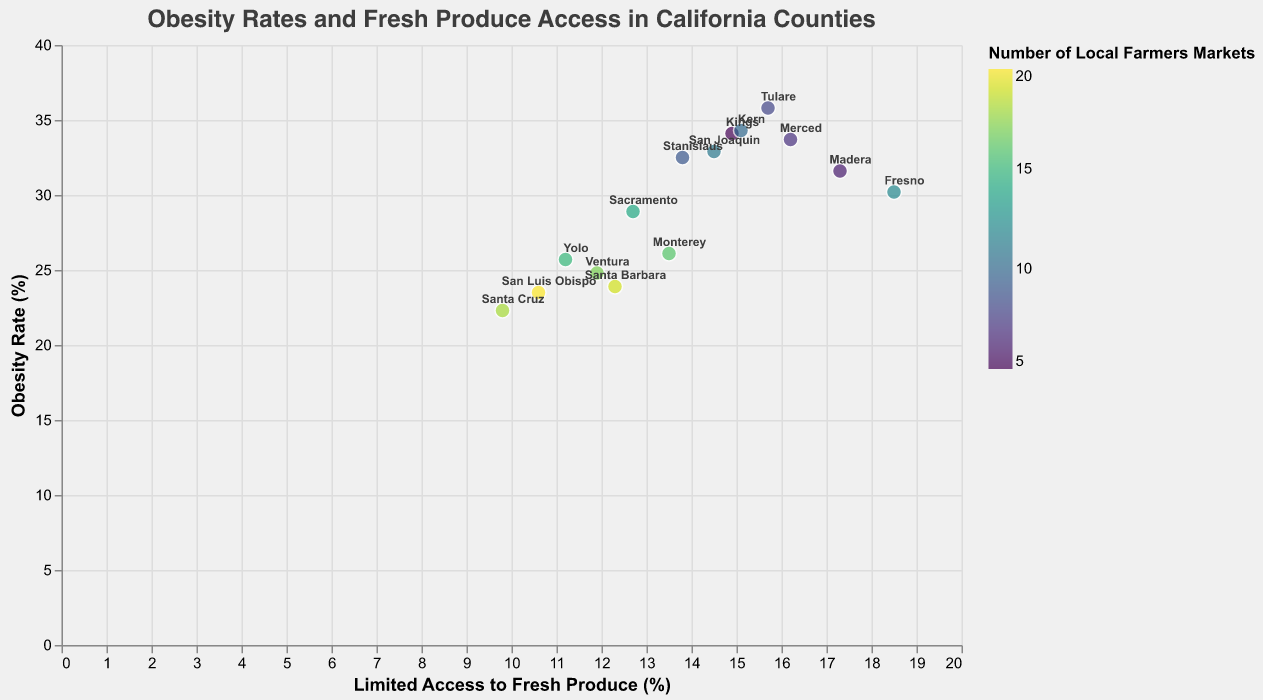What is the title of the plot? The title is displayed at the top of the plot in larger font. It reads “Obesity Rates and Fresh Produce Access in California Counties”.
Answer: Obesity Rates and Fresh Produce Access in California Counties What do the x and y-axes represent? The x-axis depicts the percentage of people with limited access to fresh produce, and the y-axis shows the obesity rate percentage in each county.
Answer: The x-axis represents Limited Access to Fresh Produce (%) and the y-axis represents Obesity Rate (%) Which county has the highest obesity rate? By looking at the highest point on the y-axis, the county with the highest obesity rate is Tulare with an obesity rate of 35.8%.
Answer: Tulare How many counties have an obesity rate higher than 30%? By examining the points above the 30% mark on the y-axis, we can count the number of counties. These points are for Fresno, Tulare, Kings, Merced, Stanislaus, San Joaquin, Madera, and Kern, making it 8 counties.
Answer: 8 Which county has the lowest access to fresh produce? By finding the point farthest to the right on the x-axis, the county with the highest value of limited access to fresh produce is Fresno with 18.5%.
Answer: Fresno Compare the number of local farmers markets in counties with obesity rates above 30% and those below. Identify counties with obesity rates above and below 30%. Above 30% includes Fresno, Tulare, Kings, Merced, Stanislaus, San Joaquin, Madera, and Kern with a total of (12+8+5+7+9+11+6+10)=68 markets. Below 30% includes Yolo, Sacramento, Santa Cruz, Monterey, San Luis Obispo, Ventura, and Santa Barbara with a total of (15+14+18+16+20+17+19)=119 markets.
Answer: Above 30%: 68 markets, Below 30%: 119 markets What's the median obesity rate for the counties plotted? Order the obesity rates: 22.3, 23.5, 23.9, 24.8, 25.7, 26.1, 28.9, 30.2, 31.6, 32.5, 32.9, 33.7, 34.1, 34.3, 35.8. The middle value (8th in a list of 15) is 30.2.
Answer: 30.2 How many counties have fewer than 10 local farmers markets? By looking at the color gradient (represented by the color of the circles) and finding those with lower numerical values, the counties with less than 10 markets are Tulare (8), Kings (5), Merced (7), and Madera (6). This makes 4 counties.
Answer: 4 Which county with the highest number of local farmers markets has an obesity rate below 25%? The highest number of markets below 25% is 20 for San Luis Obispo, which has an obesity rate of 23.5%.
Answer: San Luis Obispo Is there a correlation between limited access to fresh produce and obesity rates? The plot shows several points, but they are not aligned perfectly with any straight line. The data does not visually suggest a strong correlative trend between the percentage of people with limited access to fresh produce and the obesity rate.
Answer: No strong visible correlation 